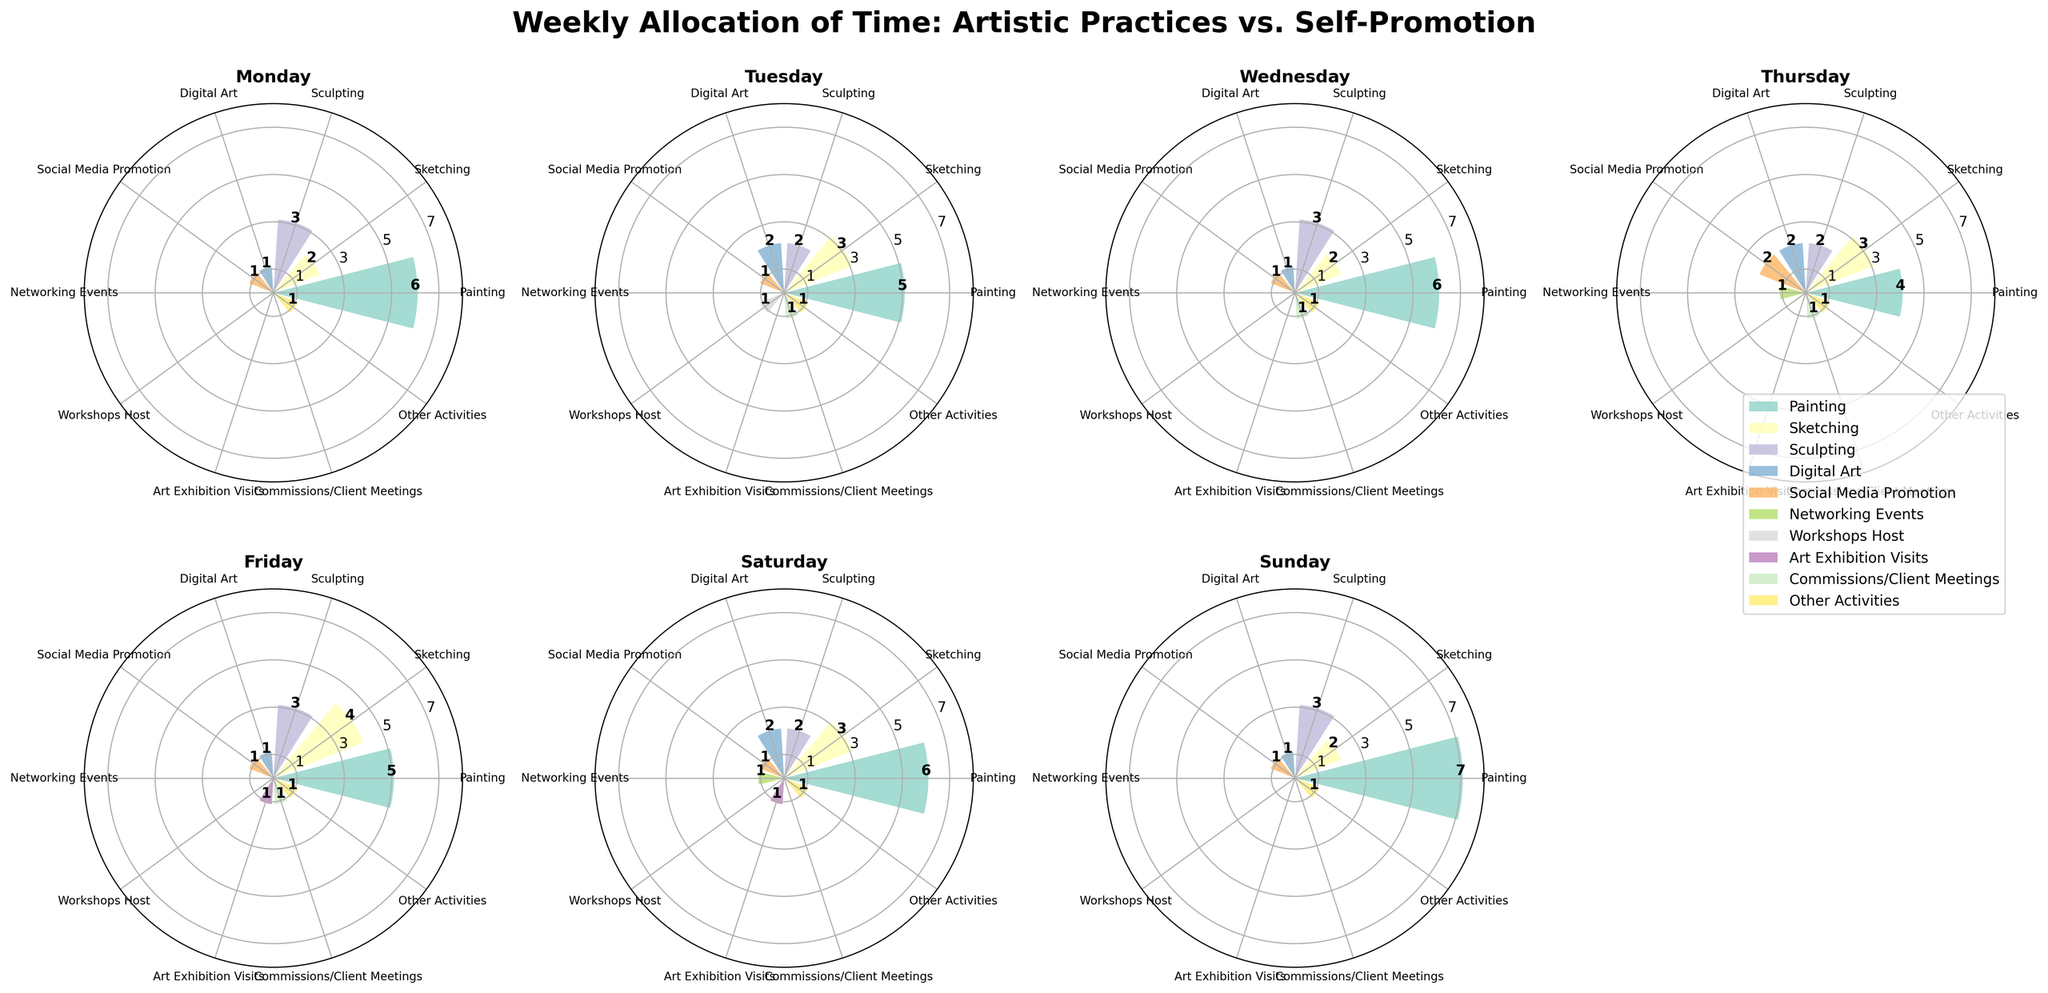What is the title of the figure? The title is located at the top of the figure, usually in a larger and bold font. The title directly describes the content of the figure: "Weekly Allocation of Time: Artistic Practices vs. Self-Promotion".
Answer: Weekly Allocation of Time: Artistic Practices vs. Self-Promotion How many activities are shown in the figure? There are multiple bars in each subplot, and each bar represents a specific activity. By counting the number of distinct bars or labels in the legend, one can find the total number of activities.
Answer: 10 Which day has the highest total time allocated to artistic practices? To determine this, assess the total time spent on artistic activities (Painting, Sketching, Sculpting, Digital Art) for each day by summing their corresponding bar lengths. Compare the totals for all days.
Answer: Sunday What activity takes the most time on Wednesday? Look at the bars for Wednesday's subplot and compare their lengths. The longest bar indicates the activity that took the most time.
Answer: Painting On which days are there no networking events? Networking events should be checked across all seven subplots to identify when the bar, if present, is zero or not plotted.
Answer: Monday, Tuesday, Wednesday, Friday, Sunday How much more time is spent painting compared to sketching on Friday? Find the values for painting and sketching on Friday by looking at their respective bars. Subtract the sketching time from the painting time.
Answer: 1 hour What is the average time spent on social media promotion throughout the week? For each day, note the time spent on social media promotion, sum these values, and divide by 7 to get the average.
Answer: (1+1+1+2+1+1+1)/7 = 1.14 hours Which day has the least amount of time allocated to commissions/client meetings? Identify the bar lengths for commissions/client meetings across all days, and find the day with the smallest value, including zeros.
Answer: Monday, Saturday, Sunday How does the time spent on digital art change from Monday to Thursday? Observe and compare the lengths of the digital art bars on Monday, Tuesday, Wednesday, and Thursday. Note the increasing or decreasing trend.
Answer: Increases from 1 hour to 2 hours What is the total time allocated to other activities for the whole week? Other activities are consistently plotted across all days with the same length. Multiply the length by 7 to get the total for the week.
Answer: 1*7 = 7 hours 